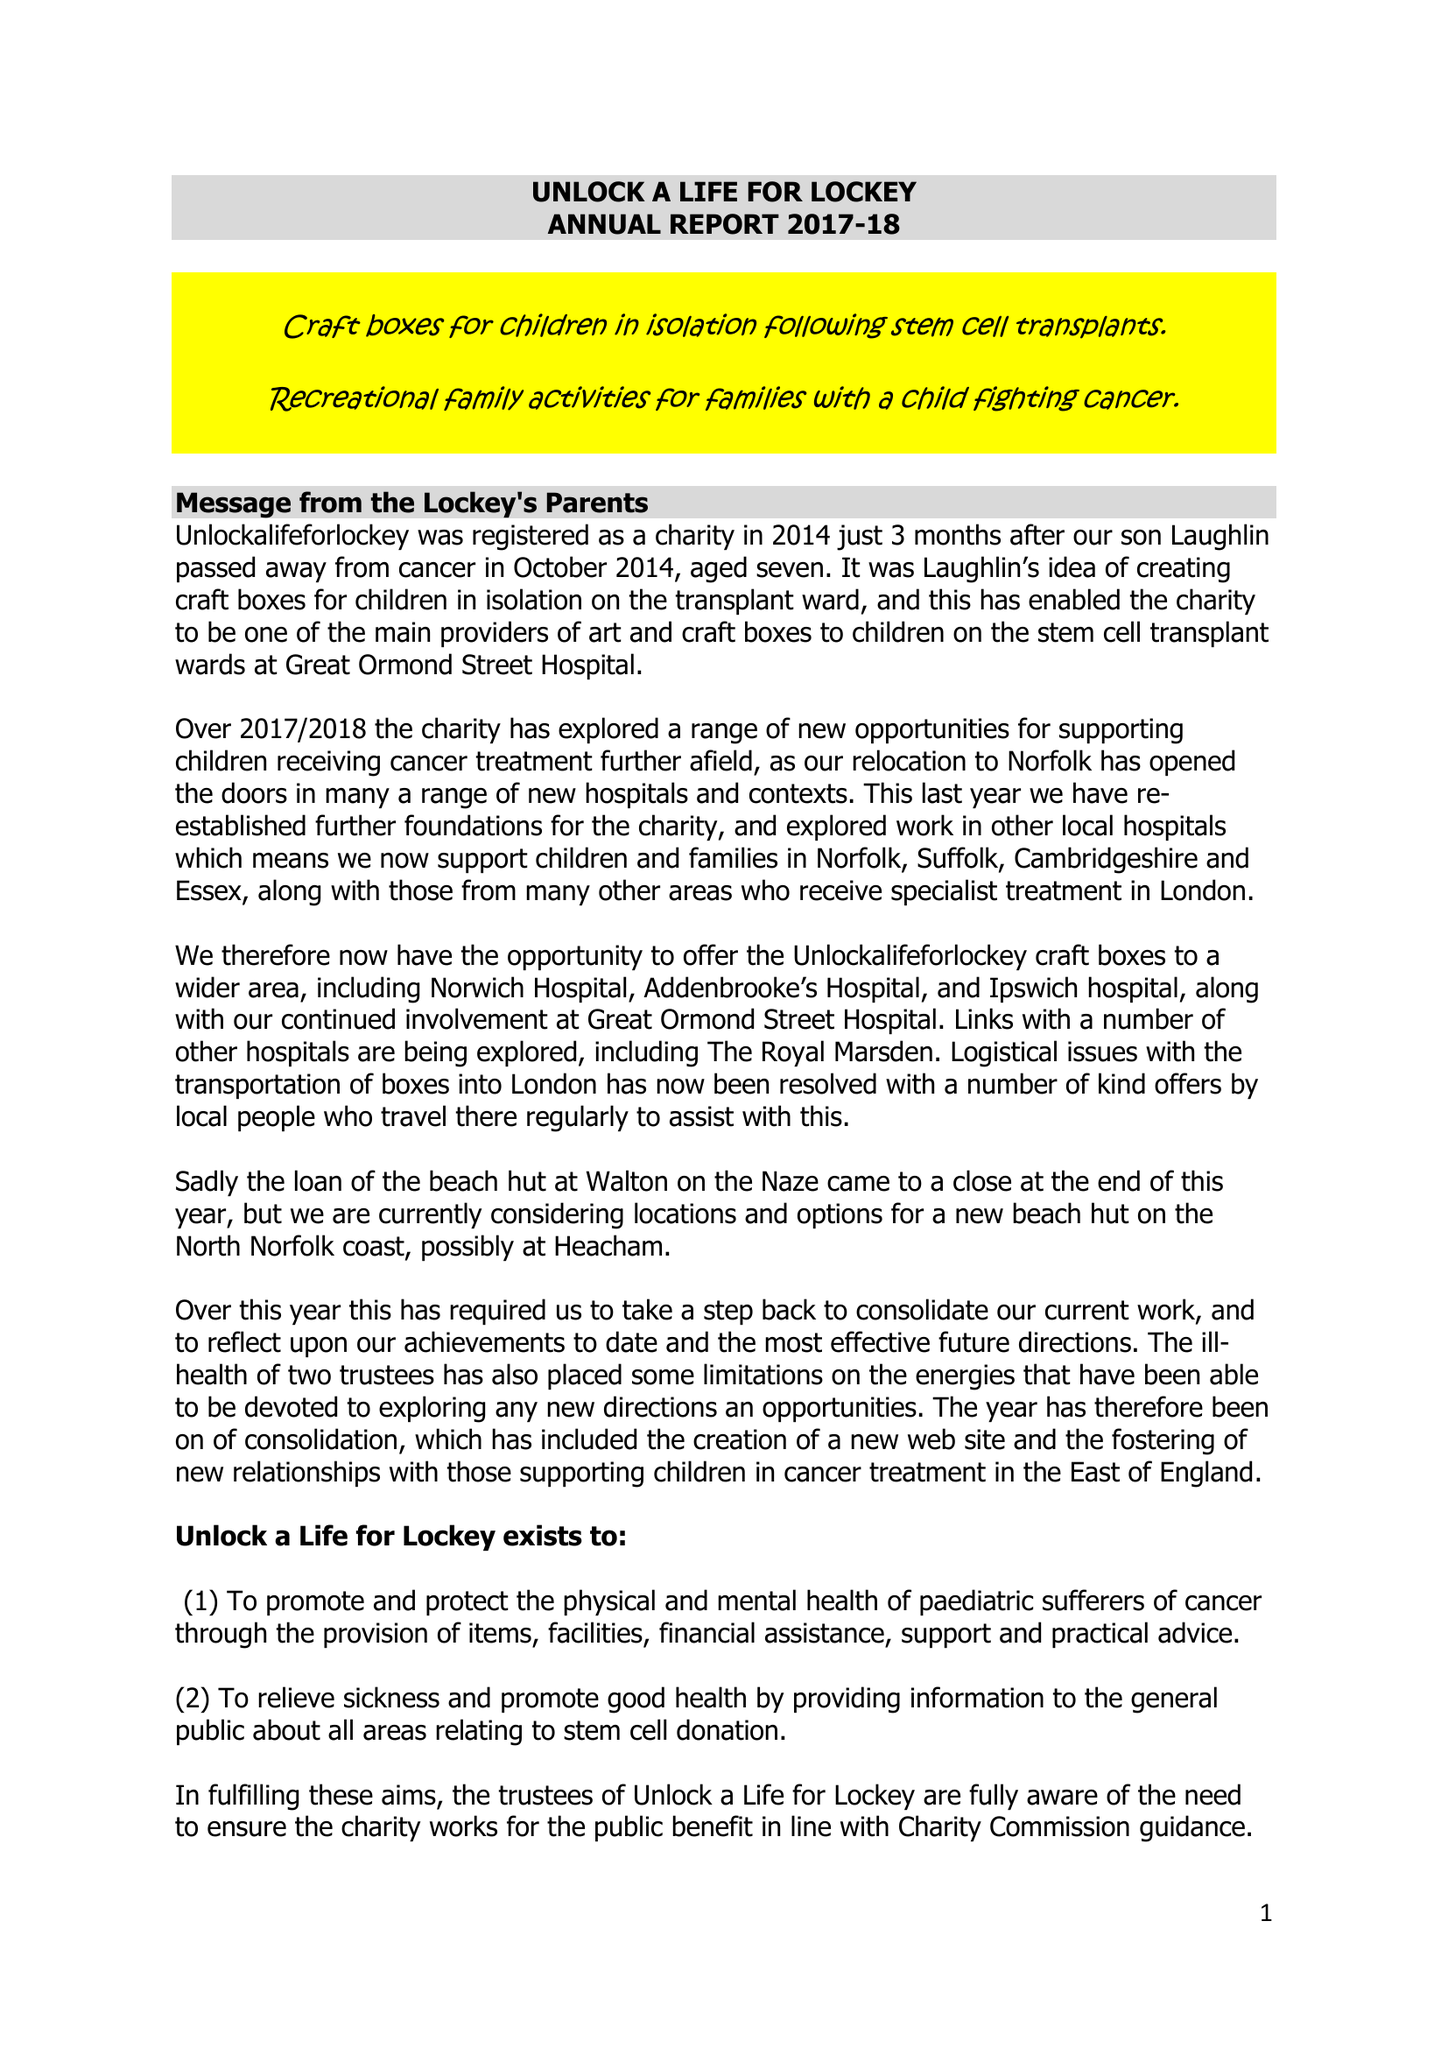What is the value for the income_annually_in_british_pounds?
Answer the question using a single word or phrase. 1521.00 